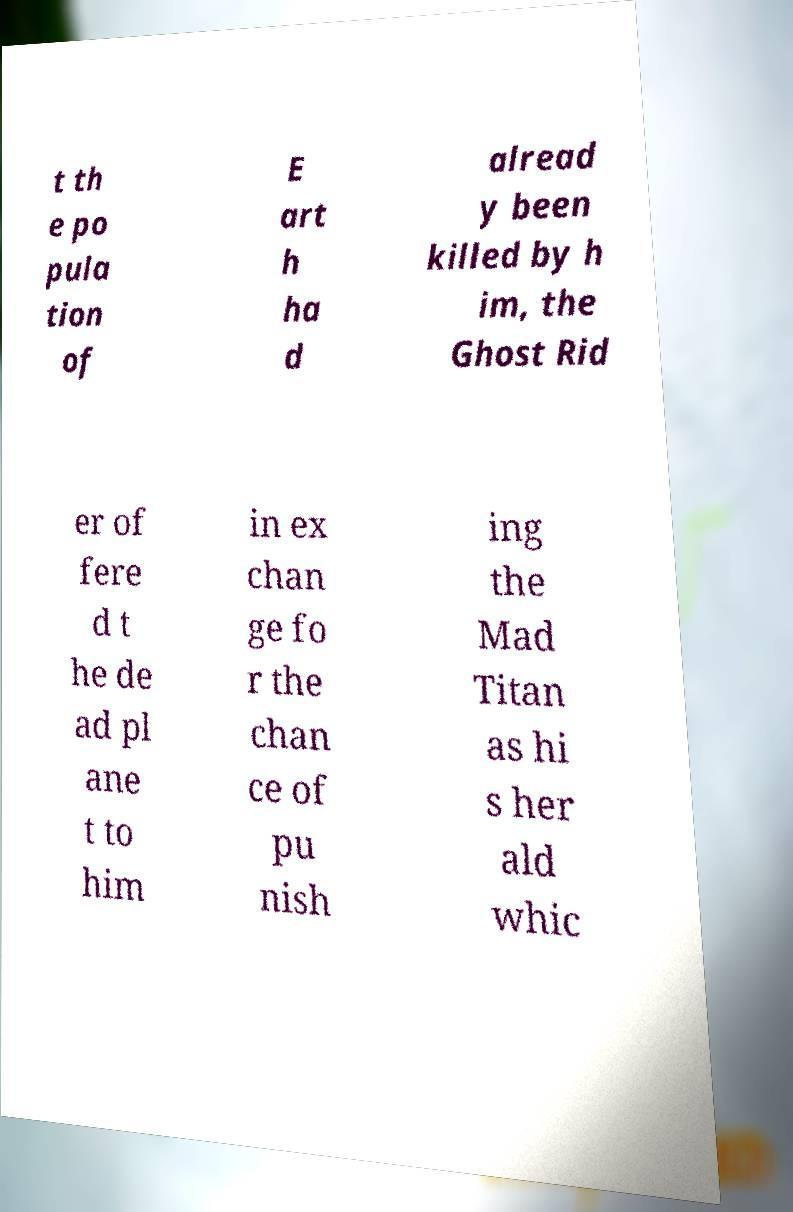For documentation purposes, I need the text within this image transcribed. Could you provide that? t th e po pula tion of E art h ha d alread y been killed by h im, the Ghost Rid er of fere d t he de ad pl ane t to him in ex chan ge fo r the chan ce of pu nish ing the Mad Titan as hi s her ald whic 